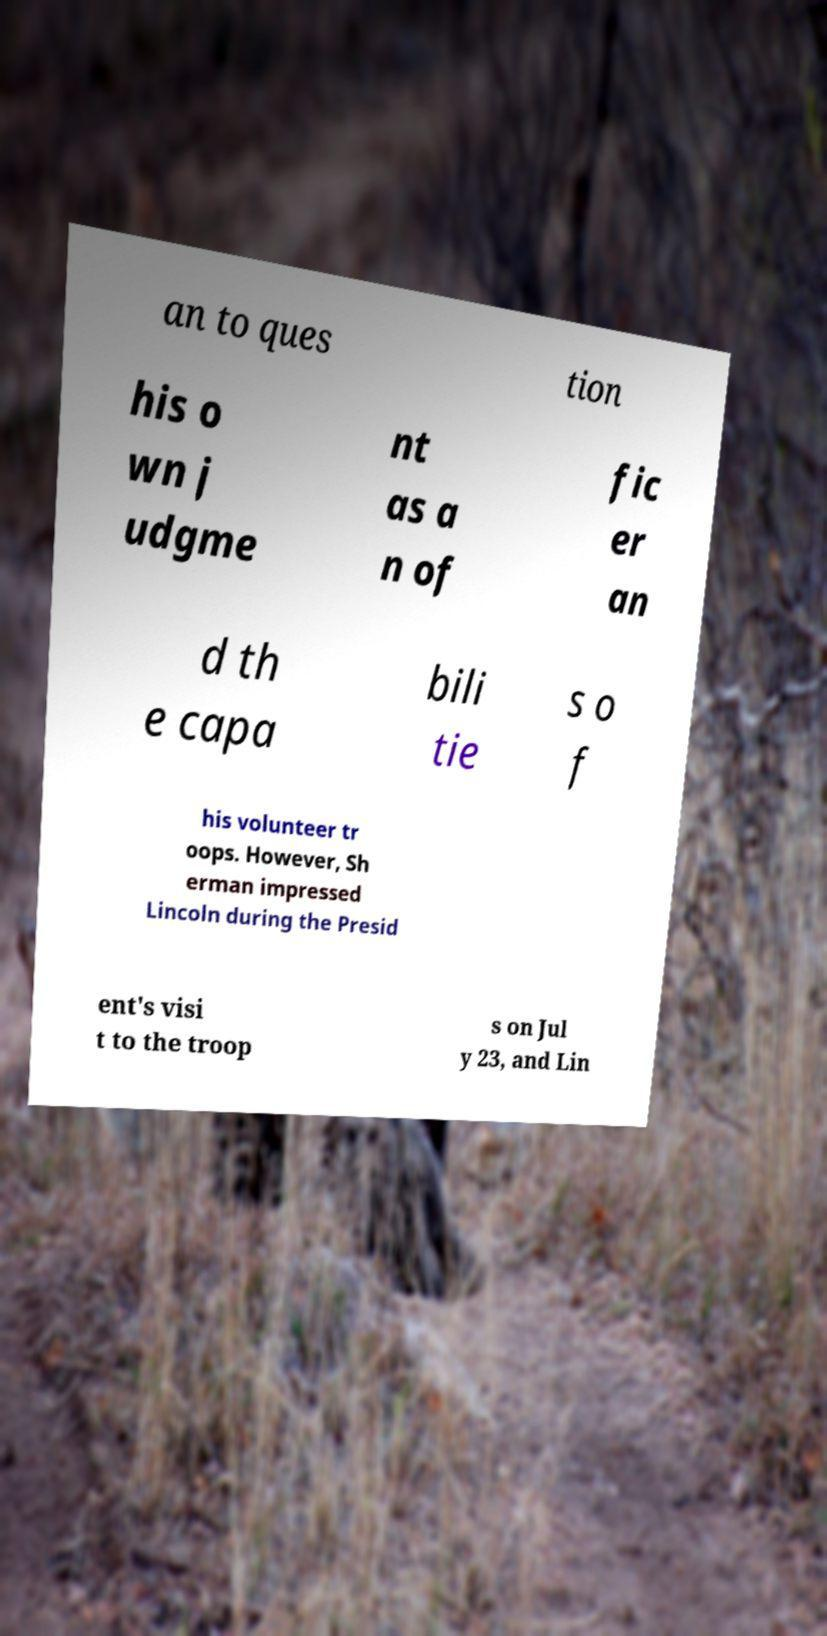Could you assist in decoding the text presented in this image and type it out clearly? an to ques tion his o wn j udgme nt as a n of fic er an d th e capa bili tie s o f his volunteer tr oops. However, Sh erman impressed Lincoln during the Presid ent's visi t to the troop s on Jul y 23, and Lin 